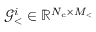<formula> <loc_0><loc_0><loc_500><loc_500>\mathcal { G } _ { < } ^ { i } \in \mathbb { R } ^ { N _ { c } \times M _ { < } }</formula> 